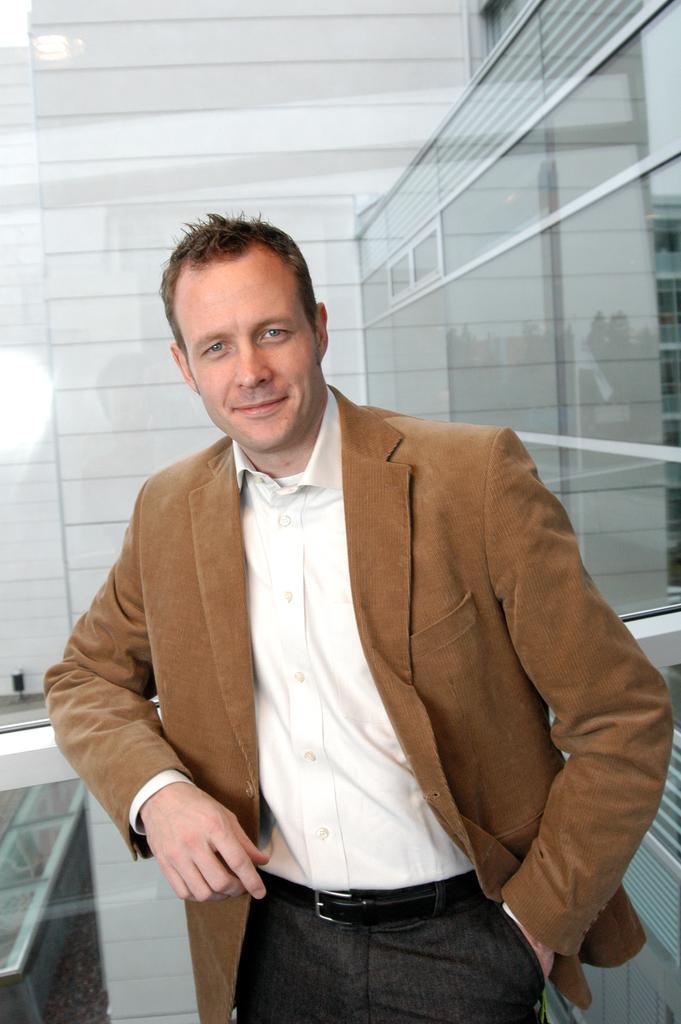In one or two sentences, can you explain what this image depicts? This picture is clicked inside. In the center there is a person wearing blazer, white color shirt, smiling and standing. In the background we can see the wall, sky, building and some other objects. 